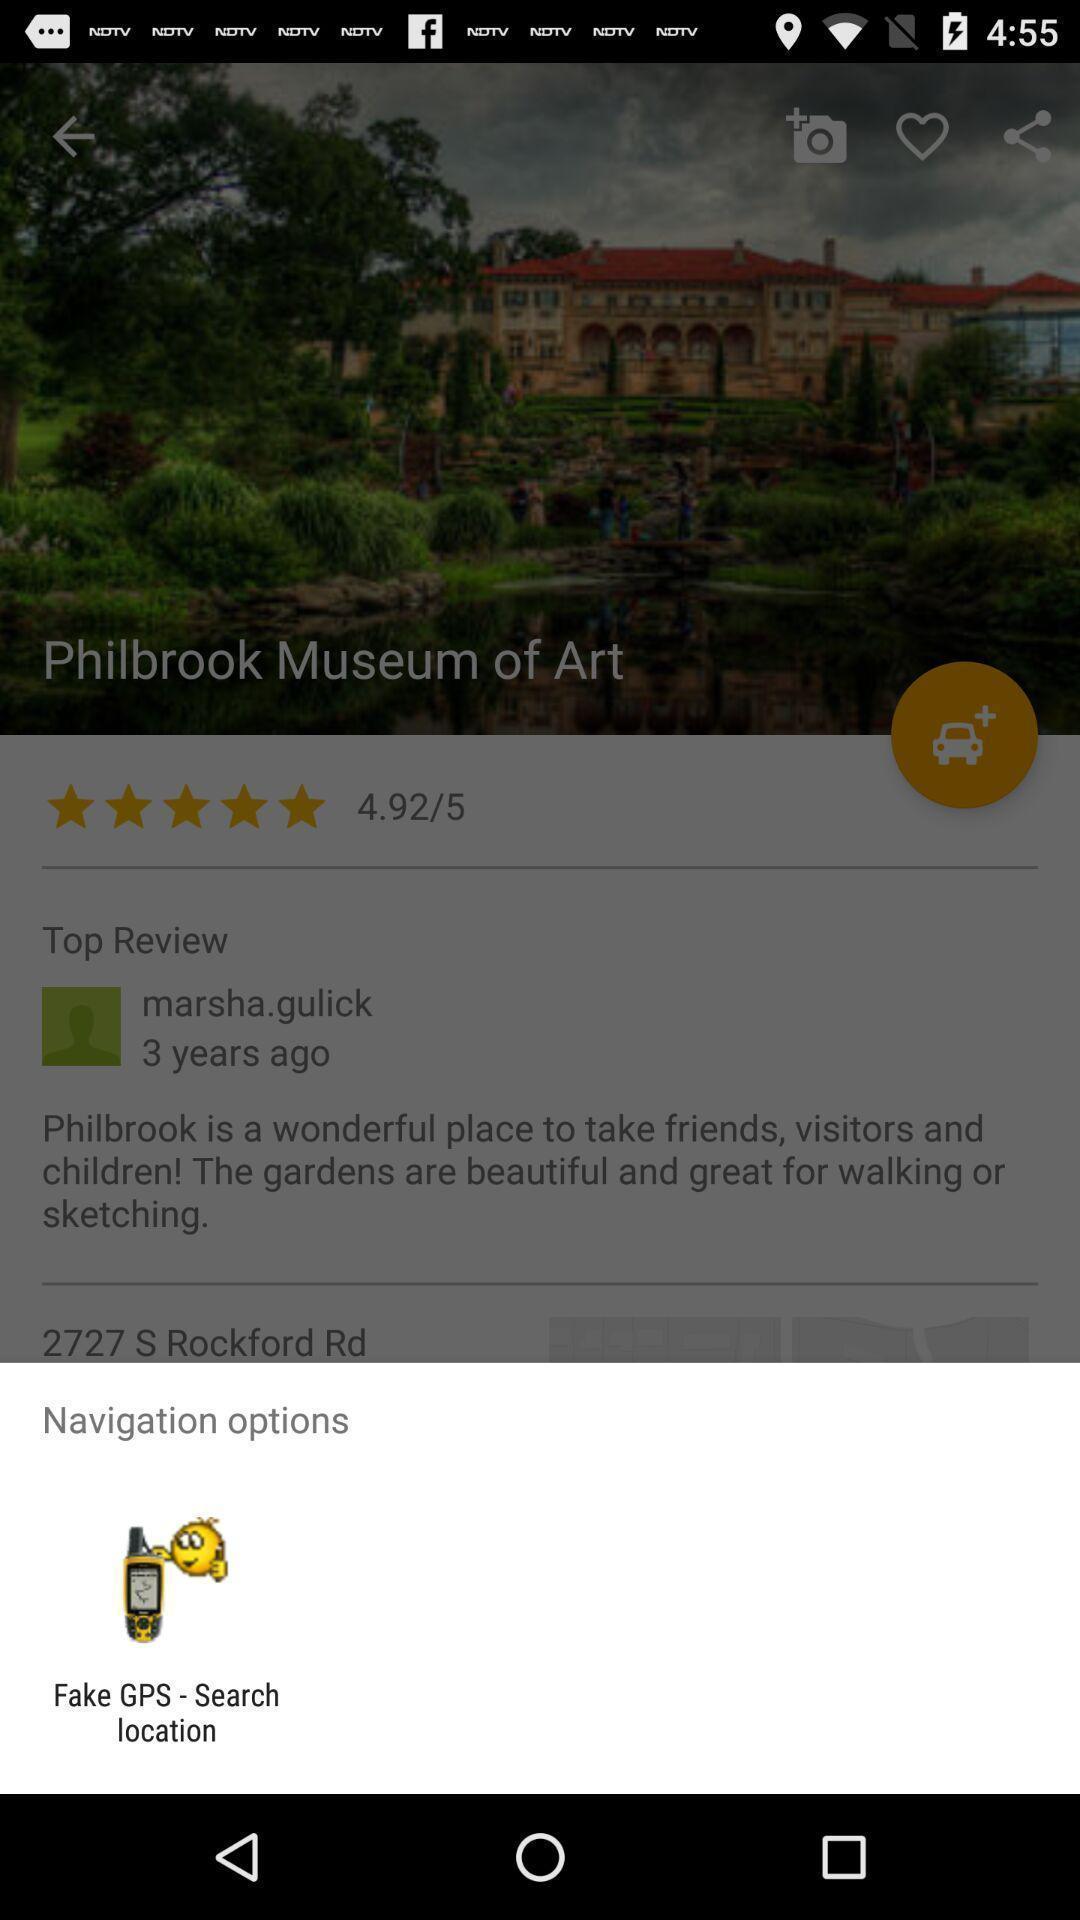Tell me what you see in this picture. Pop-up showing navigation options in a travel app. 